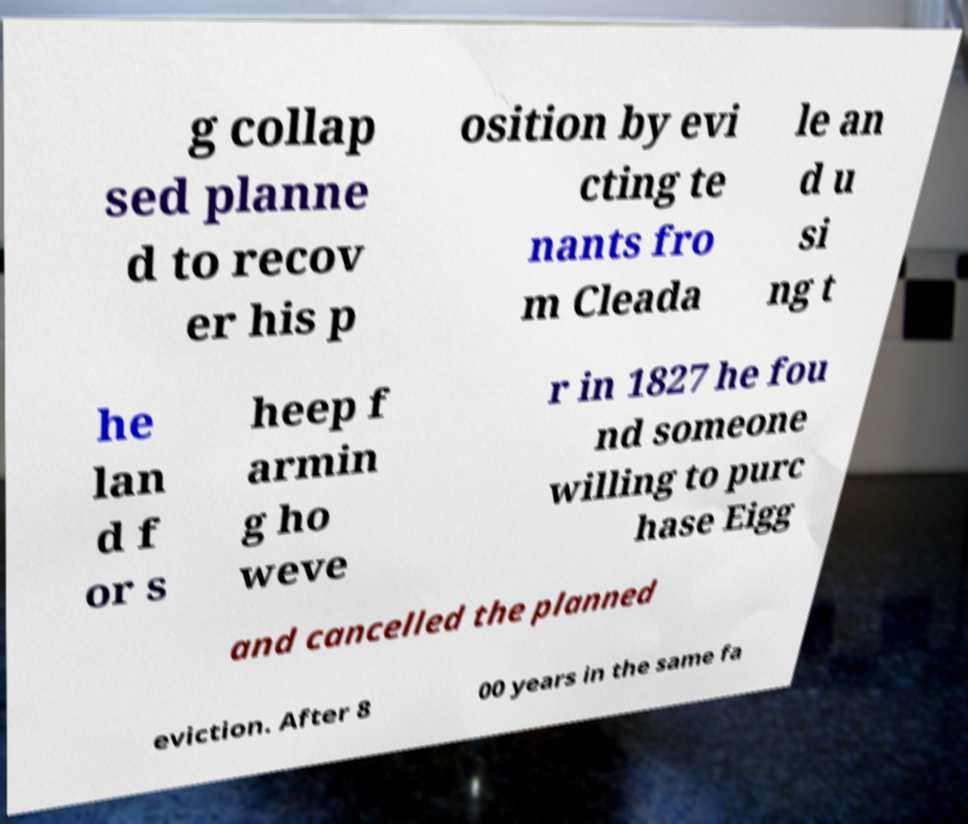Could you extract and type out the text from this image? g collap sed planne d to recov er his p osition by evi cting te nants fro m Cleada le an d u si ng t he lan d f or s heep f armin g ho weve r in 1827 he fou nd someone willing to purc hase Eigg and cancelled the planned eviction. After 8 00 years in the same fa 